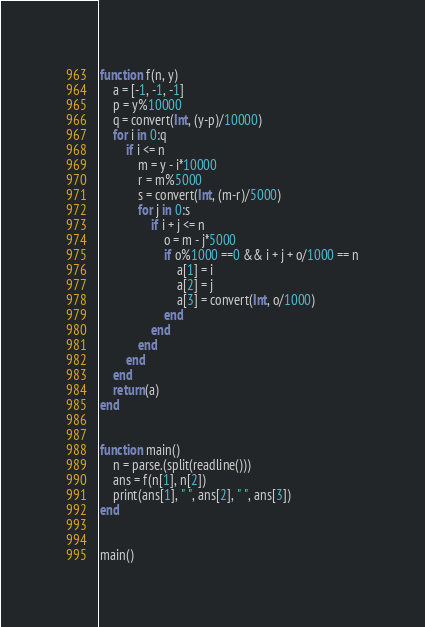<code> <loc_0><loc_0><loc_500><loc_500><_Julia_>function f(n, y)
	a = [-1, -1, -1]
	p = y%10000
	q = convert(Int, (y-p)/10000)
	for i in 0:q
		if i <= n
			m = y - i*10000
			r = m%5000
			s = convert(Int, (m-r)/5000)
			for j in 0:s
				if i + j <= n
					o = m - j*5000
					if o%1000 ==0 && i + j + o/1000 == n
						a[1] = i
						a[2] = j
						a[3] = convert(Int, o/1000)
					end
				end
			end
		end
	end
	return(a)
end


function main()
	n = parse.(split(readline()))
	ans = f(n[1], n[2])
	print(ans[1], " ", ans[2], " ", ans[3])
end


main()
</code> 